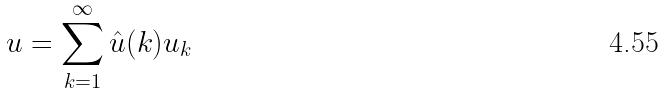Convert formula to latex. <formula><loc_0><loc_0><loc_500><loc_500>u = \sum _ { k = 1 } ^ { \infty } \hat { u } ( k ) u _ { k }</formula> 